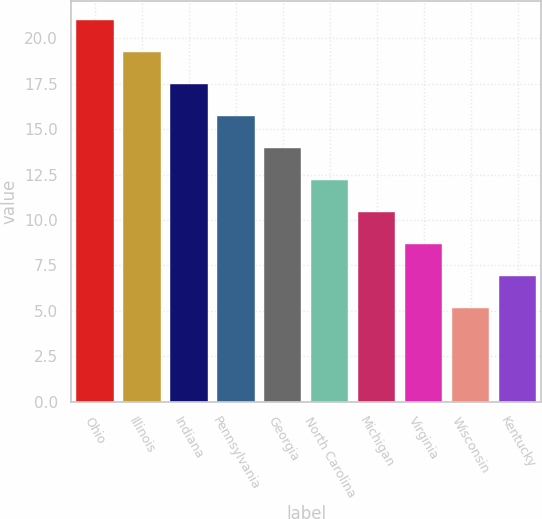Convert chart to OTSL. <chart><loc_0><loc_0><loc_500><loc_500><bar_chart><fcel>Ohio<fcel>Illinois<fcel>Indiana<fcel>Pennsylvania<fcel>Georgia<fcel>North Carolina<fcel>Michigan<fcel>Virginia<fcel>Wisconsin<fcel>Kentucky<nl><fcel>21<fcel>19.24<fcel>17.48<fcel>15.72<fcel>13.96<fcel>12.2<fcel>10.44<fcel>8.68<fcel>5.16<fcel>6.92<nl></chart> 